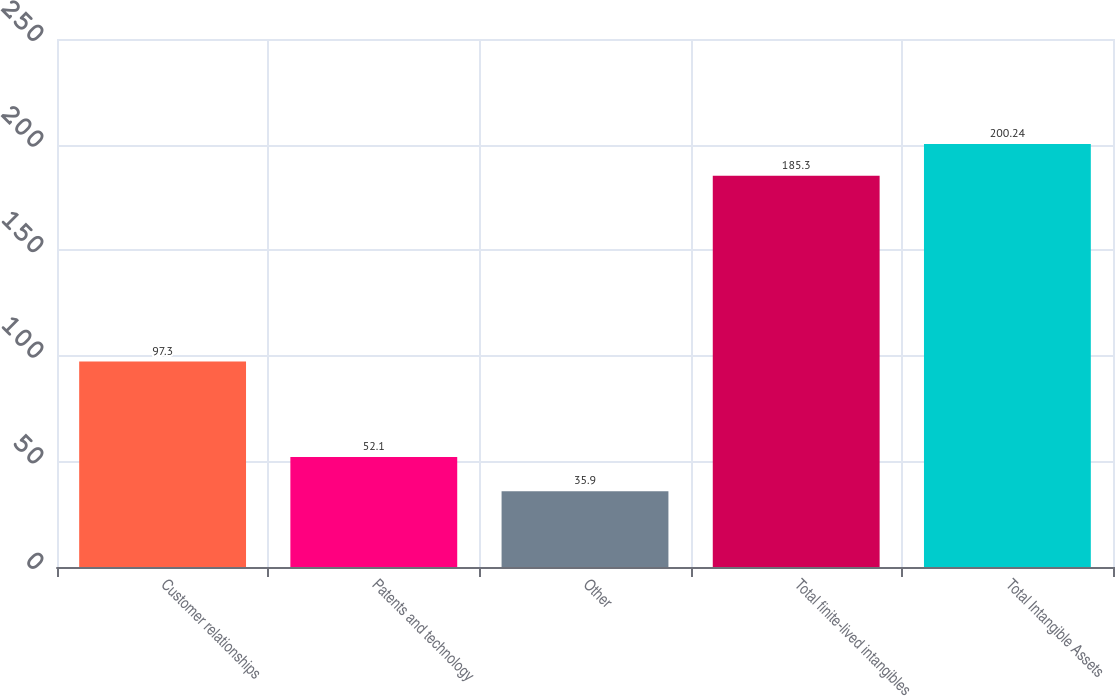Convert chart. <chart><loc_0><loc_0><loc_500><loc_500><bar_chart><fcel>Customer relationships<fcel>Patents and technology<fcel>Other<fcel>Total finite-lived intangibles<fcel>Total Intangible Assets<nl><fcel>97.3<fcel>52.1<fcel>35.9<fcel>185.3<fcel>200.24<nl></chart> 